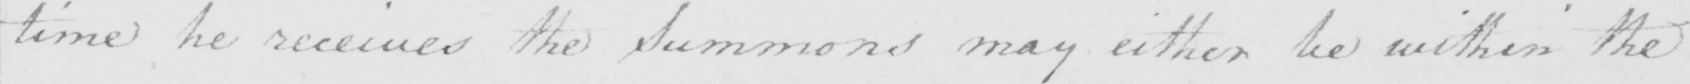Transcribe the text shown in this historical manuscript line. time he receives the Summons may either be within the 